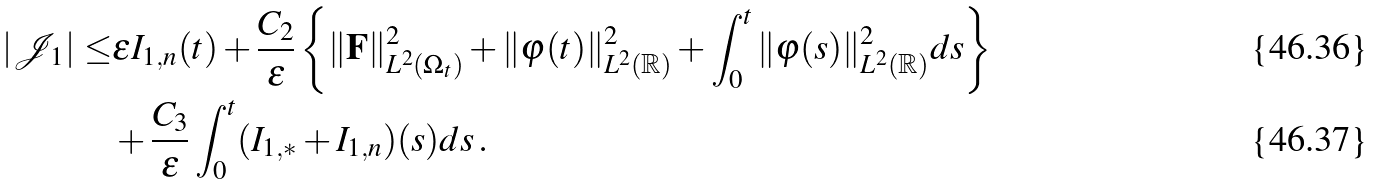Convert formula to latex. <formula><loc_0><loc_0><loc_500><loc_500>| \mathcal { J } _ { 1 } | \leq & \varepsilon I _ { 1 , n } ( t ) + \frac { C _ { 2 } } { \varepsilon } \left \{ \| { \mathbf F } \| _ { L ^ { 2 } ( \Omega _ { t } ) } ^ { 2 } + \| \varphi ( t ) \| _ { L ^ { 2 } ( \mathbb { R } ) } ^ { 2 } + \int _ { 0 } ^ { t } \| \varphi ( s ) \| ^ { 2 } _ { L ^ { 2 } ( \mathbb { R } ) } d s \right \} \\ & + \frac { C _ { 3 } } { \varepsilon } \int _ { 0 } ^ { t } ( I _ { 1 , \ast } + I _ { 1 , n } ) ( s ) d s \, .</formula> 